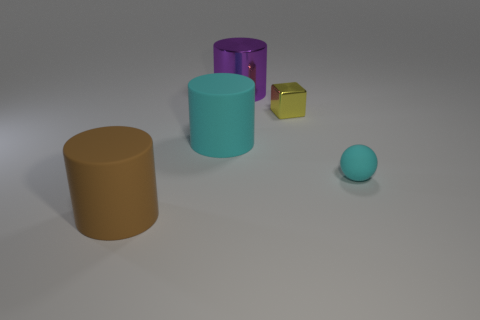What number of things are either big things that are in front of the rubber ball or rubber objects right of the big purple metallic cylinder?
Ensure brevity in your answer.  2. How many things are either cylinders or balls?
Keep it short and to the point. 4. There is a cyan object that is on the left side of the large metallic cylinder; what number of cyan matte balls are to the right of it?
Your answer should be compact. 1. How many other objects are the same size as the yellow metal block?
Keep it short and to the point. 1. The object that is the same color as the small ball is what size?
Your response must be concise. Large. There is a large brown thing left of the large cyan matte cylinder; is it the same shape as the yellow thing?
Provide a short and direct response. No. What is the material of the object behind the yellow thing?
Keep it short and to the point. Metal. There is a object that is the same color as the small matte sphere; what is its shape?
Your answer should be very brief. Cylinder. Are there any big brown cylinders that have the same material as the tiny yellow thing?
Keep it short and to the point. No. What size is the purple object?
Your answer should be compact. Large. 